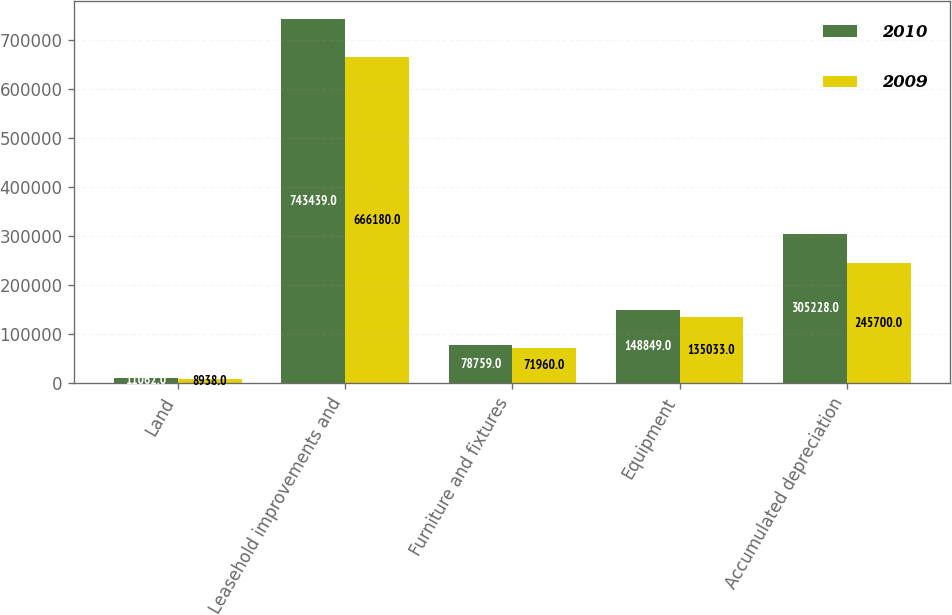Convert chart. <chart><loc_0><loc_0><loc_500><loc_500><stacked_bar_chart><ecel><fcel>Land<fcel>Leasehold improvements and<fcel>Furniture and fixtures<fcel>Equipment<fcel>Accumulated depreciation<nl><fcel>2010<fcel>11062<fcel>743439<fcel>78759<fcel>148849<fcel>305228<nl><fcel>2009<fcel>8938<fcel>666180<fcel>71960<fcel>135033<fcel>245700<nl></chart> 